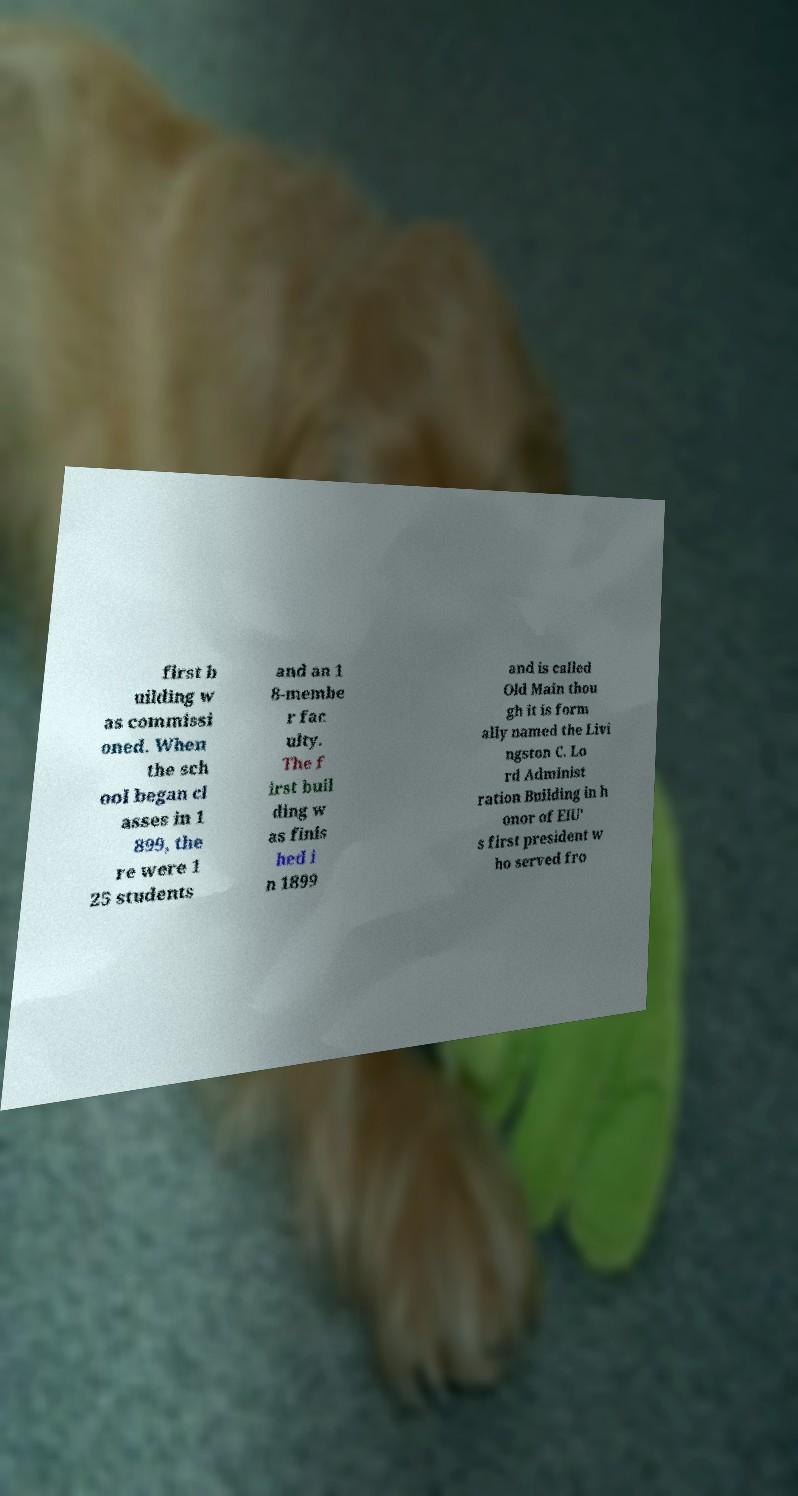Could you assist in decoding the text presented in this image and type it out clearly? first b uilding w as commissi oned. When the sch ool began cl asses in 1 899, the re were 1 25 students and an 1 8-membe r fac ulty. The f irst buil ding w as finis hed i n 1899 and is called Old Main thou gh it is form ally named the Livi ngston C. Lo rd Administ ration Building in h onor of EIU' s first president w ho served fro 